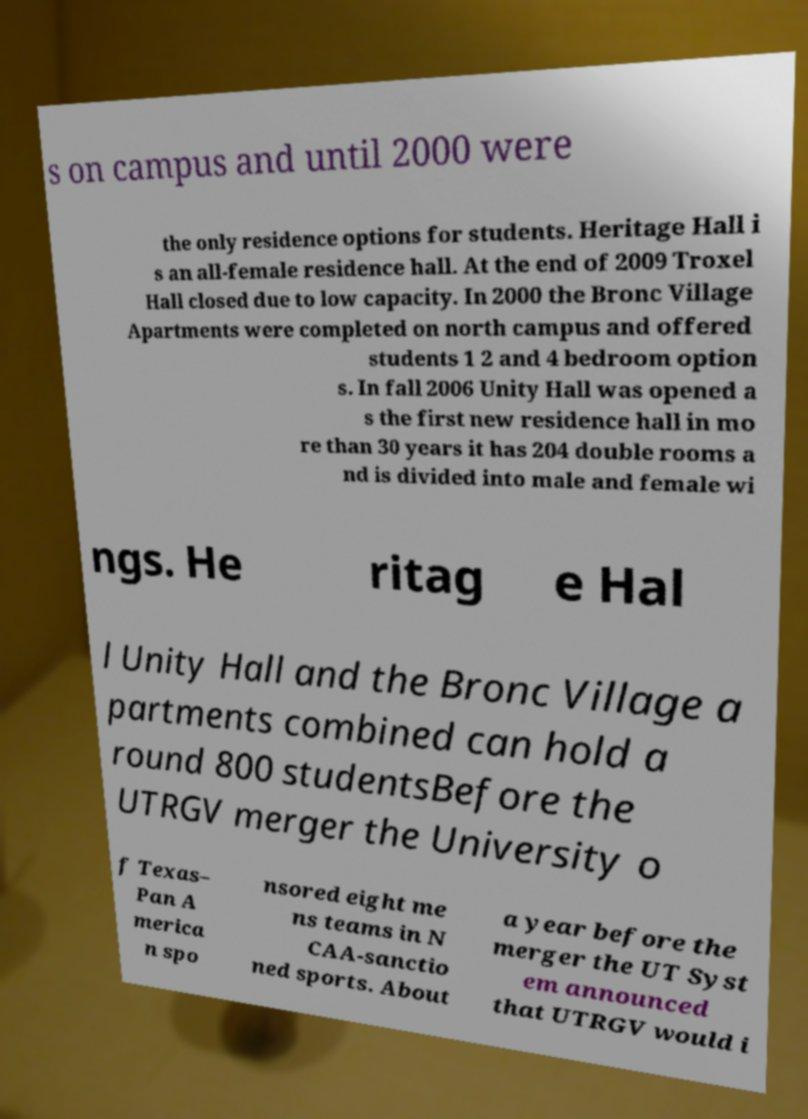Can you read and provide the text displayed in the image?This photo seems to have some interesting text. Can you extract and type it out for me? s on campus and until 2000 were the only residence options for students. Heritage Hall i s an all-female residence hall. At the end of 2009 Troxel Hall closed due to low capacity. In 2000 the Bronc Village Apartments were completed on north campus and offered students 1 2 and 4 bedroom option s. In fall 2006 Unity Hall was opened a s the first new residence hall in mo re than 30 years it has 204 double rooms a nd is divided into male and female wi ngs. He ritag e Hal l Unity Hall and the Bronc Village a partments combined can hold a round 800 studentsBefore the UTRGV merger the University o f Texas– Pan A merica n spo nsored eight me ns teams in N CAA-sanctio ned sports. About a year before the merger the UT Syst em announced that UTRGV would i 